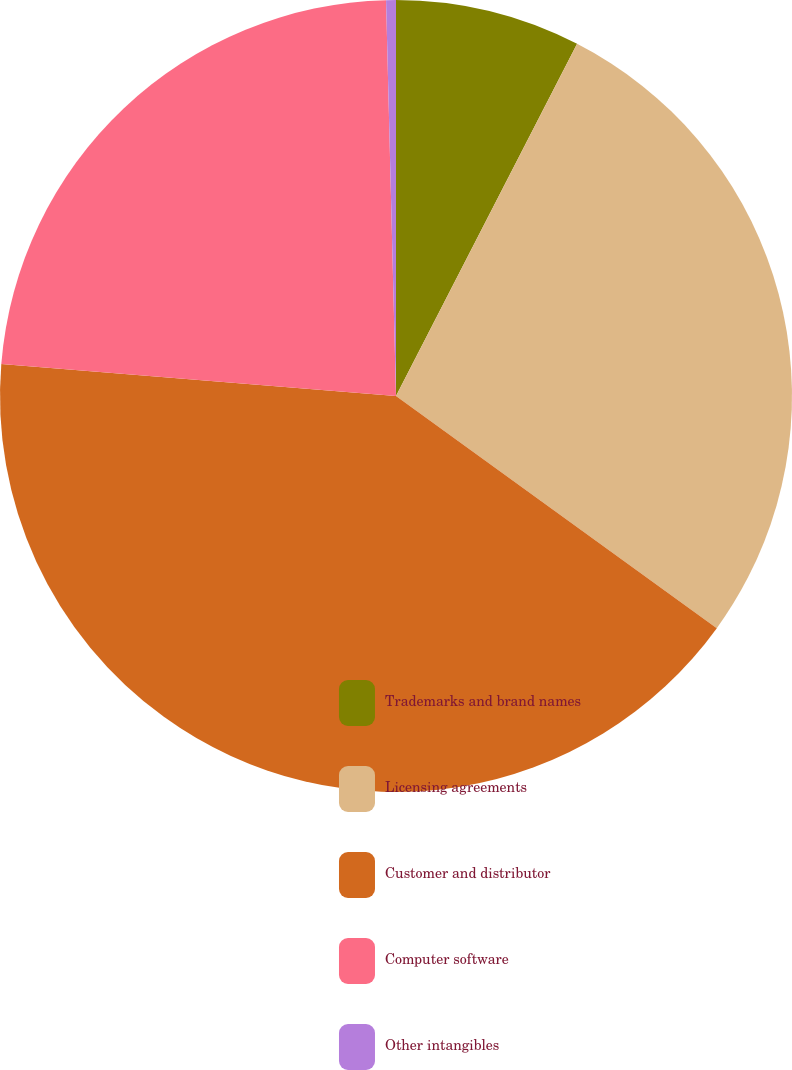Convert chart to OTSL. <chart><loc_0><loc_0><loc_500><loc_500><pie_chart><fcel>Trademarks and brand names<fcel>Licensing agreements<fcel>Customer and distributor<fcel>Computer software<fcel>Other intangibles<nl><fcel>7.56%<fcel>27.41%<fcel>41.32%<fcel>23.31%<fcel>0.4%<nl></chart> 